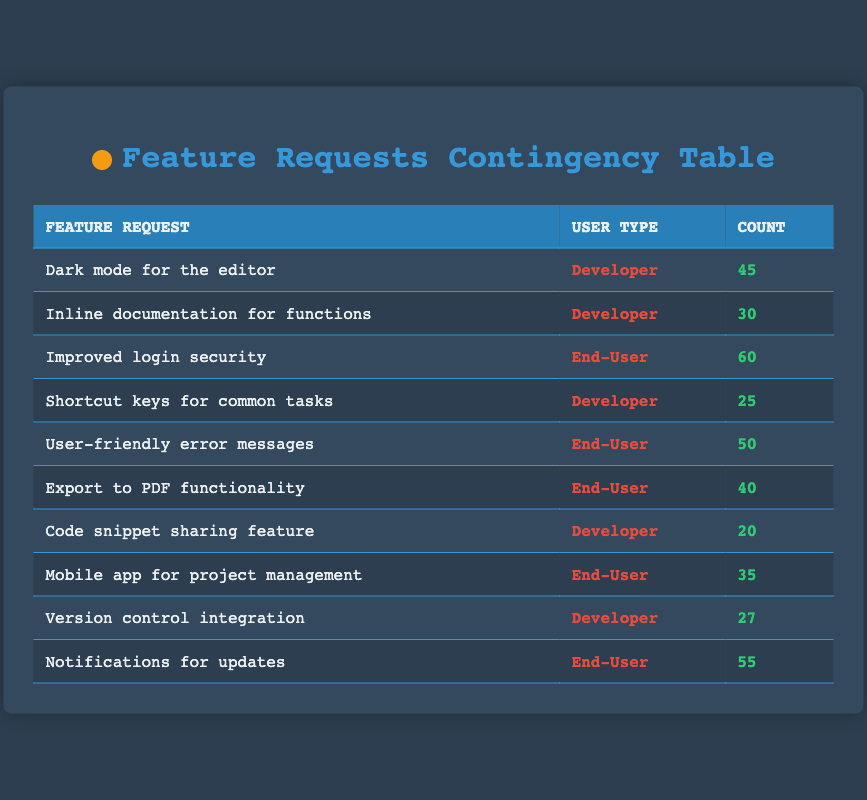What is the feature request with the highest count for developers? The table shows a total of three feature requests made by developers. Among them, "Dark mode for the editor" has the highest count of 45, compared to "Inline documentation for functions" with 30 and "Shortcut keys for common tasks" with 25.
Answer: Dark mode for the editor What is the total count of feature requests made by end-users? There are four feature requests made by end-users: "Improved login security" with 60, "User-friendly error messages" with 50, "Export to PDF functionality" with 40, and "Mobile app for project management" with 35. Adding these counts gives 60 + 50 + 40 + 35 = 185.
Answer: 185 Is there a feature request that received exactly 25 counts? Looking at the counts of feature requests in the table, the only request with a count of 25 is "Shortcut keys for common tasks." Therefore, the statement is true.
Answer: Yes What feature request did end-users make that received the lowest count? The four requests made by end-users are "Improved login security" (60), "User-friendly error messages" (50), "Export to PDF functionality" (40), and "Mobile app for project management" (35). The lowest of these is "Mobile app for project management" with 35.
Answer: Mobile app for project management What is the average count of feature requests for developers? There are five feature requests for developers: "Dark mode for the editor" (45), "Inline documentation for functions" (30), "Shortcut keys for common tasks" (25), "Code snippet sharing feature" (20), and "Version control integration" (27). Summing these counts gives 45 + 30 + 25 + 20 + 27 = 147. There are 5 requests, so the average is 147/5 = 29.4.
Answer: 29.4 